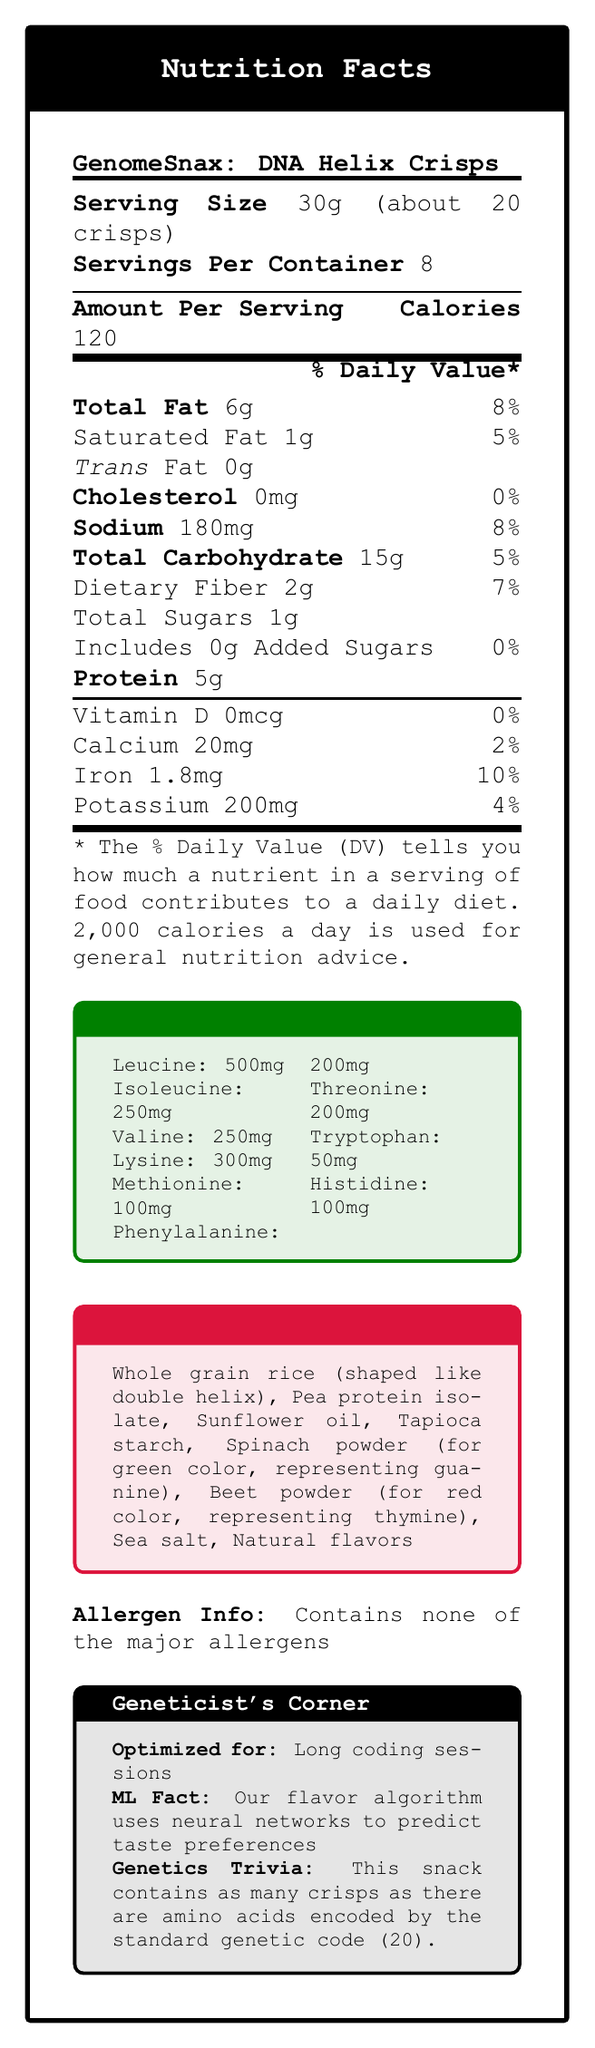what is the serving size? The serving size is listed at the beginning of the document under "Serving Size."
Answer: 30g (about 20 crisps) how many servings are there per container? The number of servings per container is indicated right below the serving size in the document.
Answer: 8 how many calories are in one serving? The number of calories per serving is explicitly noted under "Amount Per Serving" in the document.
Answer: 120 how much total fat is in one serving? The amount of total fat per serving is listed directly below the calories count.
Answer: 6g what is the % daily value of total carbohydrates in one serving? The percentage daily value of total carbohydrates is listed next to the total carbohydrate amount.
Answer: 5% what are the amino acids present in GenomeSnax: DNA Helix Crisps? A. Leucine, Isoleucine, Valine, Lysine B. Methionine, Phenylalanine, Threonine C. Tryptophan, Histidine D. All of the above The Amino Acid Profile lists all these amino acids: Leucine, Isoleucine, Valine, Lysine, Methionine, Phenylalanine, Threonine, Tryptophan, and Histidine.
Answer: D how much sodium is in one serving? The amount of sodium per serving is clearly mentioned under the amount per serving section.
Answer: 180mg what is the % daily value of iron in one serving? The % daily value of iron is listed under the minerals and vitamins section.
Answer: 10% which color ingredient represents thymine in DNA-Inspired Ingredients? A. Spinach powder B. Beet powder C. Sunflower oil D. Pea protein isolate Beet powder is used for the red color, which represents thymine, as mentioned in the DNA-Inspired Ingredients section.
Answer: B is this product free from major allergens? The document explicitly states that it contains none of the major allergens in the allergen info section.
Answer: Yes what marketing feature is emphasized for geneticists? According to the Geneticist’s Corner, the product is optimized for long coding sessions.
Answer: Optimized amino acid profile for long coding sessions does the product contain any added sugars? True or False The document states that there are 0g added sugars in the product.
Answer: False how is the flavor of the product determined, according to the document? The Geneticist’s Corner mentions that the flavor algorithm uses neural networks to predict taste preferences.
Answer: By using a neural network to predict taste preferences how many crisps are suggested to be equivalent to the number of amino acids encoded by the standard genetic code? The Genetics Trivia section mentions that the snack contains as many crisps as there are amino acids encoded by the standard genetic code, which is 20.
Answer: 20 crisps how much calcium is in one serving? The document states the amount of calcium under the minerals section.
Answer: 20mg what is the significance of the spinach powder in the ingredients? The DNA-Inspired Ingredients section states that spinach powder is used to represent guanine with its green color.
Answer: It represents guanine with its green color summarize the main purpose of the document. The document mainly focuses on the nutritional content, special ingredient choices, and unique features making the product appealing to geneticists.
Answer: The document provides detailed nutritional information for GenomeSnax: DNA Helix Crisps, including serving size, calorie count, and nutrient breakdown. It highlights the amino acid profile tailored for geneticists and the DNA-inspired ingredients, appealing to those in the field of genetics. It also emphasizes that the product is free from major allergens and utilizes a neural network for flavor prediction. what ingredients give the crisps their red and green colors? The DNA-Inspired Ingredients section specifies that spinach powder (green color) represents guanine, and beet powder (red color) represents thymine.
Answer: Spinach powder and beet powder can the document provide the exact algorithm used for flavor prediction? The document mentions that a neural network is used for flavor prediction but does not provide detailed information about the exact algorithm.
Answer: Not enough information 